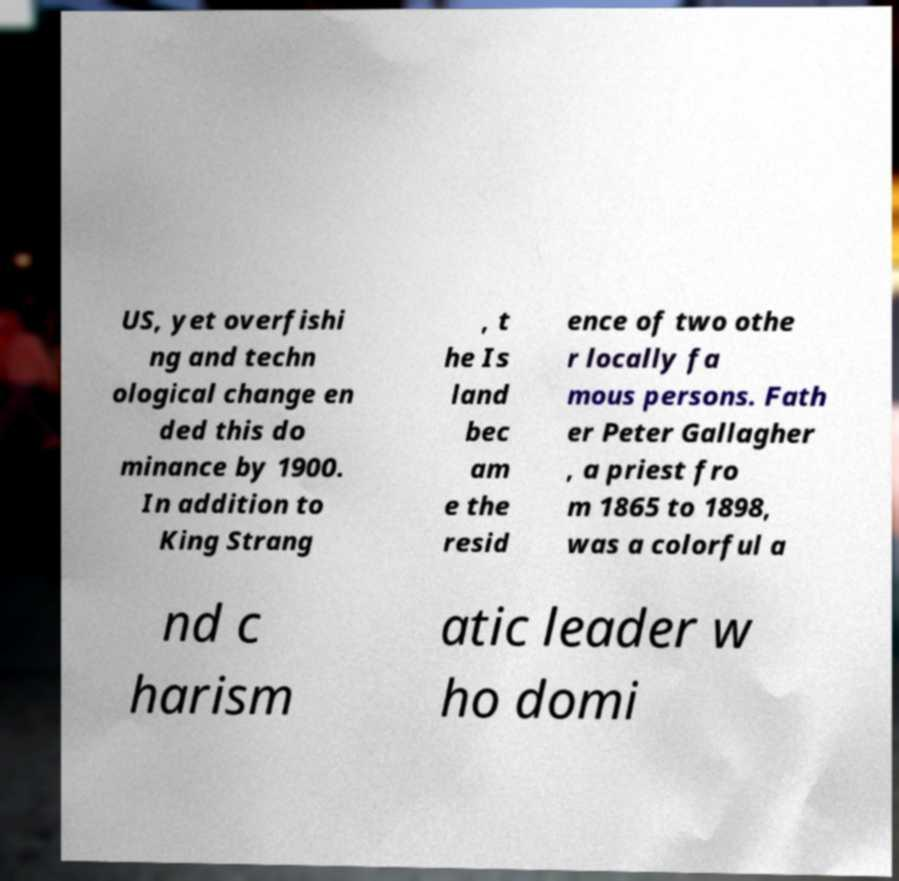I need the written content from this picture converted into text. Can you do that? US, yet overfishi ng and techn ological change en ded this do minance by 1900. In addition to King Strang , t he Is land bec am e the resid ence of two othe r locally fa mous persons. Fath er Peter Gallagher , a priest fro m 1865 to 1898, was a colorful a nd c harism atic leader w ho domi 